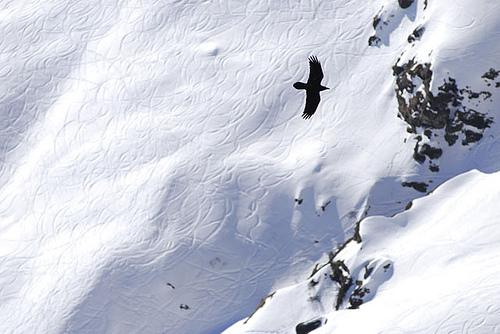Question: what color is the snow?
Choices:
A. White.
B. Yellow.
C. Grey.
D. Green.
Answer with the letter. Answer: A Question: who is flying in the sky?
Choices:
A. A helicopter.
B. A butterfly.
C. A fly.
D. A bird.
Answer with the letter. Answer: D Question: where is the bird?
Choices:
A. Flying in the sky.
B. In a nest.
C. On the grass.
D. On the fence.
Answer with the letter. Answer: A Question: how many birds are flying?
Choices:
A. Ten.
B. One.
C. Twenty.
D. Eighty.
Answer with the letter. Answer: B Question: what is in the upper right corner?
Choices:
A. The sky.
B. A child.
C. Rocks.
D. The sun.
Answer with the letter. Answer: C 